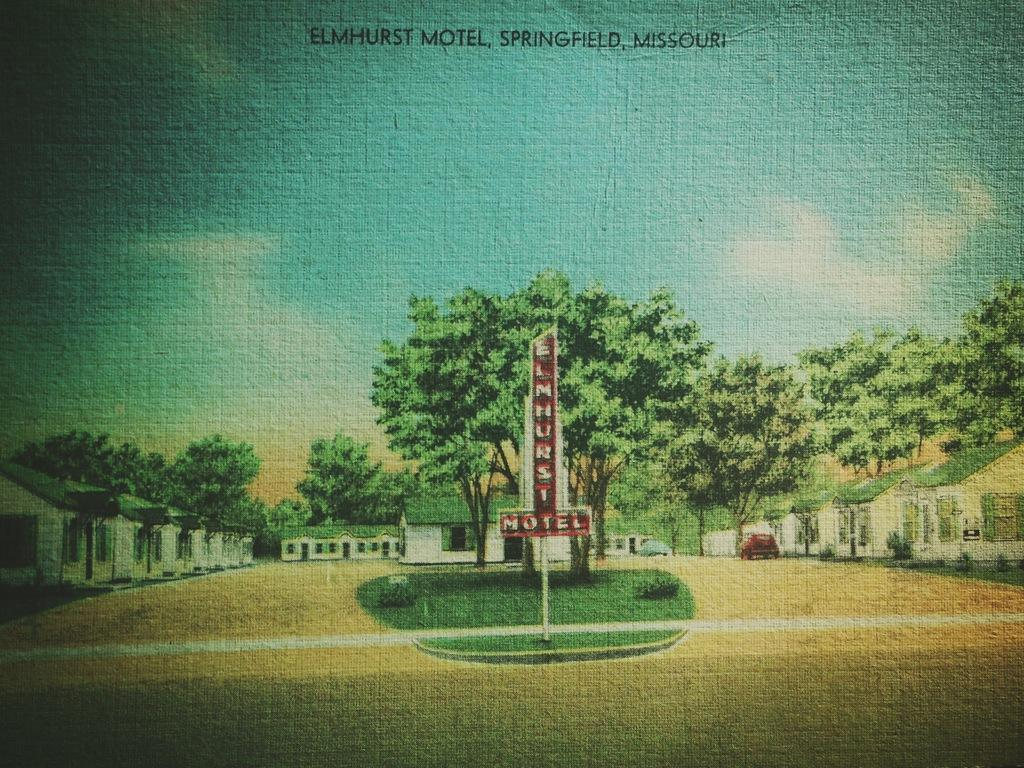What is attached to the pole in the image? There is a board attached to a pole in the image. What can be seen in the image besides the board and pole? There are trees, vehicles, buildings, and the sky in the image. Can you describe the trees in the image? The trees in the image are green. What is the color of the sky in the background? The sky in the background is blue and white. What type of disease is affecting the trees in the image? There is no indication of any disease affecting the trees in the image; they are simply green. Can you see any trails in the image? There are no trails visible in the image. 